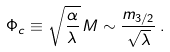<formula> <loc_0><loc_0><loc_500><loc_500>\Phi _ { c } \equiv \sqrt { \frac { \alpha } { \lambda } } \, M \sim \frac { m _ { 3 / 2 } } { \sqrt { \lambda } } \, .</formula> 